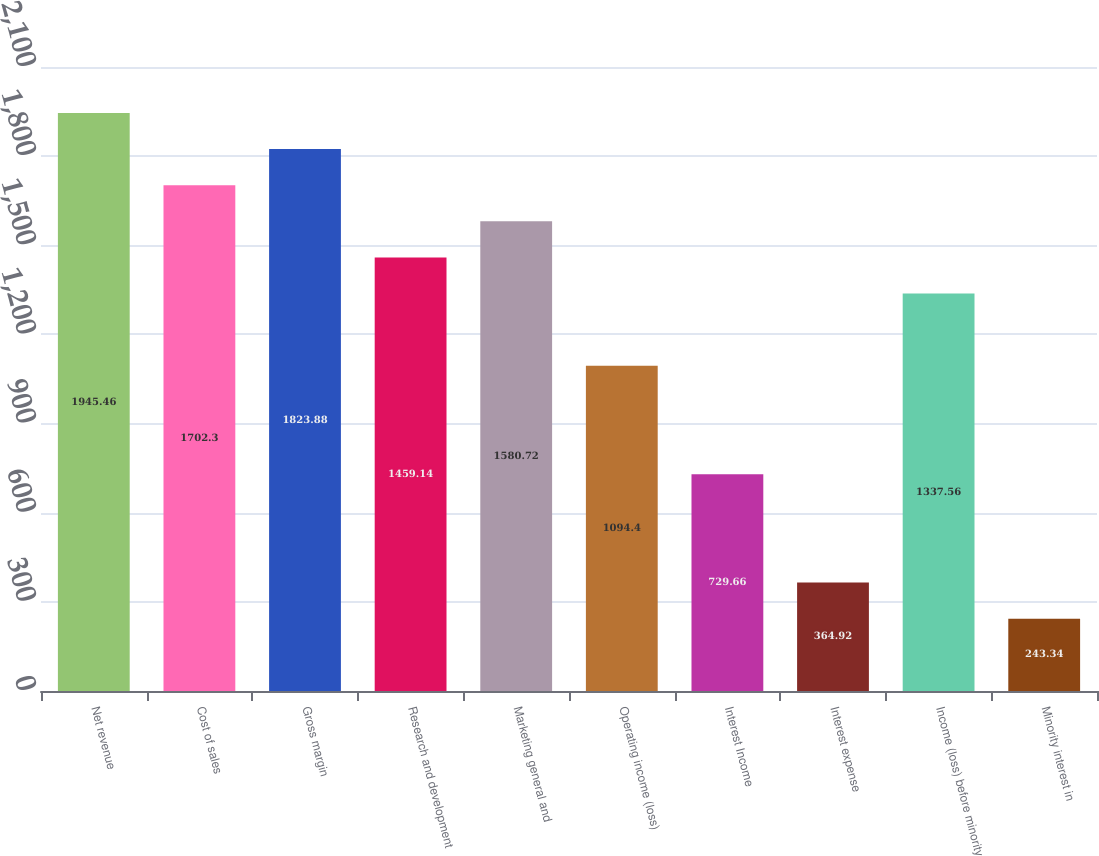Convert chart. <chart><loc_0><loc_0><loc_500><loc_500><bar_chart><fcel>Net revenue<fcel>Cost of sales<fcel>Gross margin<fcel>Research and development<fcel>Marketing general and<fcel>Operating income (loss)<fcel>Interest Income<fcel>Interest expense<fcel>Income (loss) before minority<fcel>Minority interest in<nl><fcel>1945.46<fcel>1702.3<fcel>1823.88<fcel>1459.14<fcel>1580.72<fcel>1094.4<fcel>729.66<fcel>364.92<fcel>1337.56<fcel>243.34<nl></chart> 